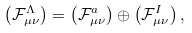Convert formula to latex. <formula><loc_0><loc_0><loc_500><loc_500>\left ( \mathcal { F } _ { \mu \nu } ^ { \Lambda } \right ) = \left ( \mathcal { F } _ { \mu \nu } ^ { a } \right ) \oplus \left ( \mathcal { F } _ { \mu \nu } ^ { I } \right ) ,</formula> 